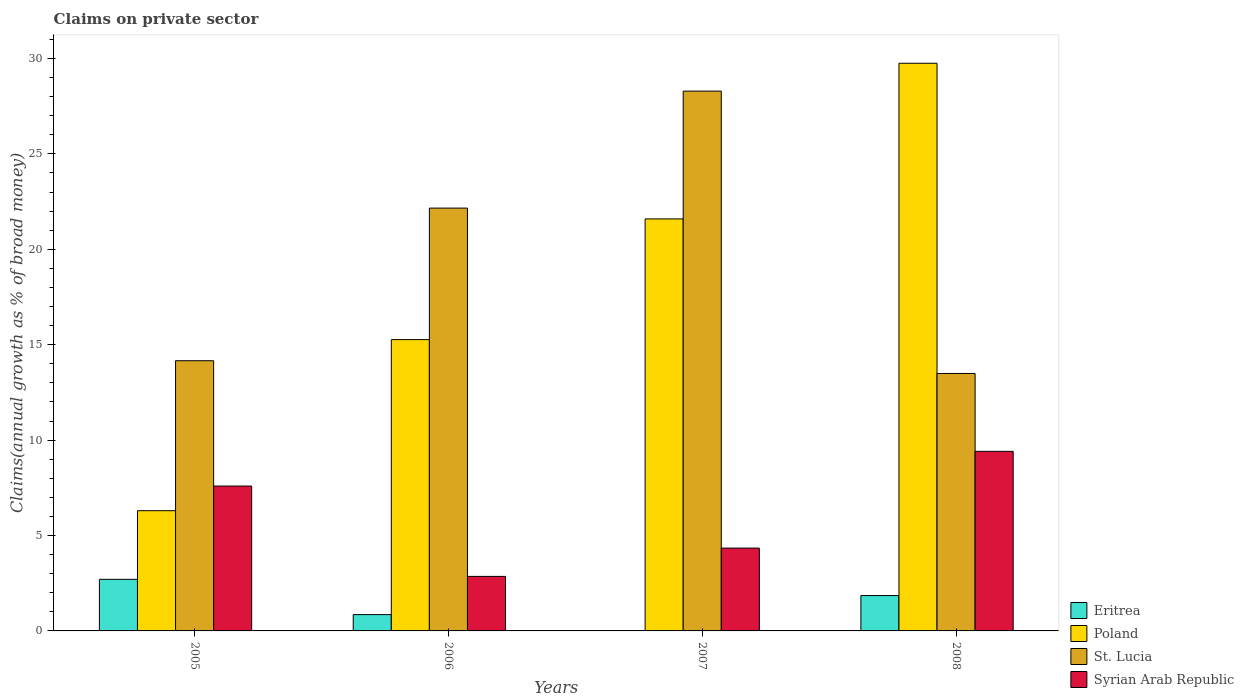How many different coloured bars are there?
Keep it short and to the point. 4. How many groups of bars are there?
Your answer should be compact. 4. Are the number of bars on each tick of the X-axis equal?
Make the answer very short. No. How many bars are there on the 4th tick from the left?
Give a very brief answer. 4. What is the label of the 4th group of bars from the left?
Offer a terse response. 2008. In how many cases, is the number of bars for a given year not equal to the number of legend labels?
Offer a very short reply. 1. What is the percentage of broad money claimed on private sector in Eritrea in 2006?
Offer a very short reply. 0.86. Across all years, what is the maximum percentage of broad money claimed on private sector in St. Lucia?
Keep it short and to the point. 28.29. Across all years, what is the minimum percentage of broad money claimed on private sector in Syrian Arab Republic?
Give a very brief answer. 2.86. In which year was the percentage of broad money claimed on private sector in St. Lucia maximum?
Give a very brief answer. 2007. What is the total percentage of broad money claimed on private sector in Poland in the graph?
Your answer should be very brief. 72.91. What is the difference between the percentage of broad money claimed on private sector in St. Lucia in 2007 and that in 2008?
Your response must be concise. 14.8. What is the difference between the percentage of broad money claimed on private sector in St. Lucia in 2007 and the percentage of broad money claimed on private sector in Poland in 2006?
Ensure brevity in your answer.  13.02. What is the average percentage of broad money claimed on private sector in Syrian Arab Republic per year?
Your answer should be very brief. 6.05. In the year 2008, what is the difference between the percentage of broad money claimed on private sector in Poland and percentage of broad money claimed on private sector in Eritrea?
Your answer should be compact. 27.9. In how many years, is the percentage of broad money claimed on private sector in St. Lucia greater than 16 %?
Ensure brevity in your answer.  2. What is the ratio of the percentage of broad money claimed on private sector in Poland in 2005 to that in 2006?
Make the answer very short. 0.41. What is the difference between the highest and the second highest percentage of broad money claimed on private sector in Eritrea?
Give a very brief answer. 0.85. What is the difference between the highest and the lowest percentage of broad money claimed on private sector in Poland?
Keep it short and to the point. 23.45. How many bars are there?
Your answer should be very brief. 15. What is the difference between two consecutive major ticks on the Y-axis?
Give a very brief answer. 5. Are the values on the major ticks of Y-axis written in scientific E-notation?
Your answer should be compact. No. Does the graph contain any zero values?
Your response must be concise. Yes. Does the graph contain grids?
Provide a short and direct response. No. How many legend labels are there?
Offer a very short reply. 4. How are the legend labels stacked?
Give a very brief answer. Vertical. What is the title of the graph?
Offer a terse response. Claims on private sector. What is the label or title of the Y-axis?
Offer a terse response. Claims(annual growth as % of broad money). What is the Claims(annual growth as % of broad money) in Eritrea in 2005?
Your answer should be very brief. 2.7. What is the Claims(annual growth as % of broad money) of Poland in 2005?
Offer a terse response. 6.3. What is the Claims(annual growth as % of broad money) in St. Lucia in 2005?
Offer a terse response. 14.16. What is the Claims(annual growth as % of broad money) of Syrian Arab Republic in 2005?
Offer a terse response. 7.59. What is the Claims(annual growth as % of broad money) of Eritrea in 2006?
Offer a terse response. 0.86. What is the Claims(annual growth as % of broad money) of Poland in 2006?
Ensure brevity in your answer.  15.27. What is the Claims(annual growth as % of broad money) in St. Lucia in 2006?
Your answer should be compact. 22.16. What is the Claims(annual growth as % of broad money) of Syrian Arab Republic in 2006?
Your answer should be very brief. 2.86. What is the Claims(annual growth as % of broad money) in Eritrea in 2007?
Provide a short and direct response. 0. What is the Claims(annual growth as % of broad money) of Poland in 2007?
Your answer should be compact. 21.59. What is the Claims(annual growth as % of broad money) of St. Lucia in 2007?
Give a very brief answer. 28.29. What is the Claims(annual growth as % of broad money) of Syrian Arab Republic in 2007?
Ensure brevity in your answer.  4.34. What is the Claims(annual growth as % of broad money) of Eritrea in 2008?
Provide a short and direct response. 1.85. What is the Claims(annual growth as % of broad money) in Poland in 2008?
Keep it short and to the point. 29.75. What is the Claims(annual growth as % of broad money) in St. Lucia in 2008?
Provide a short and direct response. 13.49. What is the Claims(annual growth as % of broad money) of Syrian Arab Republic in 2008?
Your answer should be very brief. 9.41. Across all years, what is the maximum Claims(annual growth as % of broad money) in Eritrea?
Your answer should be compact. 2.7. Across all years, what is the maximum Claims(annual growth as % of broad money) in Poland?
Make the answer very short. 29.75. Across all years, what is the maximum Claims(annual growth as % of broad money) in St. Lucia?
Offer a very short reply. 28.29. Across all years, what is the maximum Claims(annual growth as % of broad money) of Syrian Arab Republic?
Your response must be concise. 9.41. Across all years, what is the minimum Claims(annual growth as % of broad money) of Eritrea?
Give a very brief answer. 0. Across all years, what is the minimum Claims(annual growth as % of broad money) of Poland?
Your answer should be very brief. 6.3. Across all years, what is the minimum Claims(annual growth as % of broad money) in St. Lucia?
Make the answer very short. 13.49. Across all years, what is the minimum Claims(annual growth as % of broad money) in Syrian Arab Republic?
Your answer should be compact. 2.86. What is the total Claims(annual growth as % of broad money) in Eritrea in the graph?
Provide a succinct answer. 5.41. What is the total Claims(annual growth as % of broad money) in Poland in the graph?
Offer a terse response. 72.91. What is the total Claims(annual growth as % of broad money) of St. Lucia in the graph?
Provide a short and direct response. 78.1. What is the total Claims(annual growth as % of broad money) in Syrian Arab Republic in the graph?
Offer a very short reply. 24.2. What is the difference between the Claims(annual growth as % of broad money) of Eritrea in 2005 and that in 2006?
Provide a short and direct response. 1.85. What is the difference between the Claims(annual growth as % of broad money) of Poland in 2005 and that in 2006?
Offer a terse response. -8.97. What is the difference between the Claims(annual growth as % of broad money) of St. Lucia in 2005 and that in 2006?
Keep it short and to the point. -8. What is the difference between the Claims(annual growth as % of broad money) of Syrian Arab Republic in 2005 and that in 2006?
Offer a very short reply. 4.74. What is the difference between the Claims(annual growth as % of broad money) in Poland in 2005 and that in 2007?
Keep it short and to the point. -15.29. What is the difference between the Claims(annual growth as % of broad money) in St. Lucia in 2005 and that in 2007?
Your answer should be compact. -14.13. What is the difference between the Claims(annual growth as % of broad money) of Syrian Arab Republic in 2005 and that in 2007?
Provide a succinct answer. 3.25. What is the difference between the Claims(annual growth as % of broad money) of Eritrea in 2005 and that in 2008?
Give a very brief answer. 0.85. What is the difference between the Claims(annual growth as % of broad money) in Poland in 2005 and that in 2008?
Offer a terse response. -23.45. What is the difference between the Claims(annual growth as % of broad money) of St. Lucia in 2005 and that in 2008?
Make the answer very short. 0.67. What is the difference between the Claims(annual growth as % of broad money) of Syrian Arab Republic in 2005 and that in 2008?
Provide a succinct answer. -1.82. What is the difference between the Claims(annual growth as % of broad money) of Poland in 2006 and that in 2007?
Provide a succinct answer. -6.33. What is the difference between the Claims(annual growth as % of broad money) of St. Lucia in 2006 and that in 2007?
Ensure brevity in your answer.  -6.13. What is the difference between the Claims(annual growth as % of broad money) in Syrian Arab Republic in 2006 and that in 2007?
Keep it short and to the point. -1.48. What is the difference between the Claims(annual growth as % of broad money) of Eritrea in 2006 and that in 2008?
Offer a terse response. -1. What is the difference between the Claims(annual growth as % of broad money) of Poland in 2006 and that in 2008?
Your answer should be very brief. -14.48. What is the difference between the Claims(annual growth as % of broad money) of St. Lucia in 2006 and that in 2008?
Your answer should be very brief. 8.67. What is the difference between the Claims(annual growth as % of broad money) in Syrian Arab Republic in 2006 and that in 2008?
Keep it short and to the point. -6.55. What is the difference between the Claims(annual growth as % of broad money) of Poland in 2007 and that in 2008?
Your answer should be compact. -8.16. What is the difference between the Claims(annual growth as % of broad money) in St. Lucia in 2007 and that in 2008?
Make the answer very short. 14.8. What is the difference between the Claims(annual growth as % of broad money) of Syrian Arab Republic in 2007 and that in 2008?
Provide a short and direct response. -5.07. What is the difference between the Claims(annual growth as % of broad money) of Eritrea in 2005 and the Claims(annual growth as % of broad money) of Poland in 2006?
Your answer should be compact. -12.56. What is the difference between the Claims(annual growth as % of broad money) in Eritrea in 2005 and the Claims(annual growth as % of broad money) in St. Lucia in 2006?
Your response must be concise. -19.46. What is the difference between the Claims(annual growth as % of broad money) of Eritrea in 2005 and the Claims(annual growth as % of broad money) of Syrian Arab Republic in 2006?
Your answer should be compact. -0.15. What is the difference between the Claims(annual growth as % of broad money) of Poland in 2005 and the Claims(annual growth as % of broad money) of St. Lucia in 2006?
Your answer should be compact. -15.86. What is the difference between the Claims(annual growth as % of broad money) of Poland in 2005 and the Claims(annual growth as % of broad money) of Syrian Arab Republic in 2006?
Provide a succinct answer. 3.44. What is the difference between the Claims(annual growth as % of broad money) of St. Lucia in 2005 and the Claims(annual growth as % of broad money) of Syrian Arab Republic in 2006?
Make the answer very short. 11.3. What is the difference between the Claims(annual growth as % of broad money) in Eritrea in 2005 and the Claims(annual growth as % of broad money) in Poland in 2007?
Offer a very short reply. -18.89. What is the difference between the Claims(annual growth as % of broad money) of Eritrea in 2005 and the Claims(annual growth as % of broad money) of St. Lucia in 2007?
Provide a short and direct response. -25.59. What is the difference between the Claims(annual growth as % of broad money) of Eritrea in 2005 and the Claims(annual growth as % of broad money) of Syrian Arab Republic in 2007?
Your response must be concise. -1.64. What is the difference between the Claims(annual growth as % of broad money) in Poland in 2005 and the Claims(annual growth as % of broad money) in St. Lucia in 2007?
Provide a short and direct response. -21.99. What is the difference between the Claims(annual growth as % of broad money) of Poland in 2005 and the Claims(annual growth as % of broad money) of Syrian Arab Republic in 2007?
Your answer should be compact. 1.96. What is the difference between the Claims(annual growth as % of broad money) in St. Lucia in 2005 and the Claims(annual growth as % of broad money) in Syrian Arab Republic in 2007?
Make the answer very short. 9.82. What is the difference between the Claims(annual growth as % of broad money) of Eritrea in 2005 and the Claims(annual growth as % of broad money) of Poland in 2008?
Make the answer very short. -27.05. What is the difference between the Claims(annual growth as % of broad money) in Eritrea in 2005 and the Claims(annual growth as % of broad money) in St. Lucia in 2008?
Your answer should be compact. -10.79. What is the difference between the Claims(annual growth as % of broad money) in Eritrea in 2005 and the Claims(annual growth as % of broad money) in Syrian Arab Republic in 2008?
Provide a short and direct response. -6.71. What is the difference between the Claims(annual growth as % of broad money) of Poland in 2005 and the Claims(annual growth as % of broad money) of St. Lucia in 2008?
Make the answer very short. -7.19. What is the difference between the Claims(annual growth as % of broad money) of Poland in 2005 and the Claims(annual growth as % of broad money) of Syrian Arab Republic in 2008?
Offer a terse response. -3.11. What is the difference between the Claims(annual growth as % of broad money) of St. Lucia in 2005 and the Claims(annual growth as % of broad money) of Syrian Arab Republic in 2008?
Give a very brief answer. 4.75. What is the difference between the Claims(annual growth as % of broad money) of Eritrea in 2006 and the Claims(annual growth as % of broad money) of Poland in 2007?
Your answer should be compact. -20.74. What is the difference between the Claims(annual growth as % of broad money) in Eritrea in 2006 and the Claims(annual growth as % of broad money) in St. Lucia in 2007?
Your response must be concise. -27.44. What is the difference between the Claims(annual growth as % of broad money) of Eritrea in 2006 and the Claims(annual growth as % of broad money) of Syrian Arab Republic in 2007?
Your response must be concise. -3.49. What is the difference between the Claims(annual growth as % of broad money) in Poland in 2006 and the Claims(annual growth as % of broad money) in St. Lucia in 2007?
Your response must be concise. -13.02. What is the difference between the Claims(annual growth as % of broad money) in Poland in 2006 and the Claims(annual growth as % of broad money) in Syrian Arab Republic in 2007?
Offer a terse response. 10.93. What is the difference between the Claims(annual growth as % of broad money) of St. Lucia in 2006 and the Claims(annual growth as % of broad money) of Syrian Arab Republic in 2007?
Provide a short and direct response. 17.82. What is the difference between the Claims(annual growth as % of broad money) of Eritrea in 2006 and the Claims(annual growth as % of broad money) of Poland in 2008?
Your response must be concise. -28.9. What is the difference between the Claims(annual growth as % of broad money) in Eritrea in 2006 and the Claims(annual growth as % of broad money) in St. Lucia in 2008?
Ensure brevity in your answer.  -12.64. What is the difference between the Claims(annual growth as % of broad money) of Eritrea in 2006 and the Claims(annual growth as % of broad money) of Syrian Arab Republic in 2008?
Offer a terse response. -8.56. What is the difference between the Claims(annual growth as % of broad money) of Poland in 2006 and the Claims(annual growth as % of broad money) of St. Lucia in 2008?
Give a very brief answer. 1.78. What is the difference between the Claims(annual growth as % of broad money) of Poland in 2006 and the Claims(annual growth as % of broad money) of Syrian Arab Republic in 2008?
Make the answer very short. 5.86. What is the difference between the Claims(annual growth as % of broad money) of St. Lucia in 2006 and the Claims(annual growth as % of broad money) of Syrian Arab Republic in 2008?
Provide a short and direct response. 12.75. What is the difference between the Claims(annual growth as % of broad money) of Poland in 2007 and the Claims(annual growth as % of broad money) of St. Lucia in 2008?
Your answer should be very brief. 8.1. What is the difference between the Claims(annual growth as % of broad money) in Poland in 2007 and the Claims(annual growth as % of broad money) in Syrian Arab Republic in 2008?
Give a very brief answer. 12.18. What is the difference between the Claims(annual growth as % of broad money) in St. Lucia in 2007 and the Claims(annual growth as % of broad money) in Syrian Arab Republic in 2008?
Make the answer very short. 18.88. What is the average Claims(annual growth as % of broad money) in Eritrea per year?
Make the answer very short. 1.35. What is the average Claims(annual growth as % of broad money) in Poland per year?
Make the answer very short. 18.23. What is the average Claims(annual growth as % of broad money) of St. Lucia per year?
Your response must be concise. 19.53. What is the average Claims(annual growth as % of broad money) of Syrian Arab Republic per year?
Offer a terse response. 6.05. In the year 2005, what is the difference between the Claims(annual growth as % of broad money) in Eritrea and Claims(annual growth as % of broad money) in Poland?
Offer a terse response. -3.6. In the year 2005, what is the difference between the Claims(annual growth as % of broad money) of Eritrea and Claims(annual growth as % of broad money) of St. Lucia?
Your answer should be very brief. -11.46. In the year 2005, what is the difference between the Claims(annual growth as % of broad money) in Eritrea and Claims(annual growth as % of broad money) in Syrian Arab Republic?
Your answer should be very brief. -4.89. In the year 2005, what is the difference between the Claims(annual growth as % of broad money) of Poland and Claims(annual growth as % of broad money) of St. Lucia?
Keep it short and to the point. -7.86. In the year 2005, what is the difference between the Claims(annual growth as % of broad money) in Poland and Claims(annual growth as % of broad money) in Syrian Arab Republic?
Keep it short and to the point. -1.29. In the year 2005, what is the difference between the Claims(annual growth as % of broad money) of St. Lucia and Claims(annual growth as % of broad money) of Syrian Arab Republic?
Provide a short and direct response. 6.57. In the year 2006, what is the difference between the Claims(annual growth as % of broad money) in Eritrea and Claims(annual growth as % of broad money) in Poland?
Your answer should be very brief. -14.41. In the year 2006, what is the difference between the Claims(annual growth as % of broad money) of Eritrea and Claims(annual growth as % of broad money) of St. Lucia?
Your answer should be compact. -21.3. In the year 2006, what is the difference between the Claims(annual growth as % of broad money) of Eritrea and Claims(annual growth as % of broad money) of Syrian Arab Republic?
Make the answer very short. -2. In the year 2006, what is the difference between the Claims(annual growth as % of broad money) in Poland and Claims(annual growth as % of broad money) in St. Lucia?
Give a very brief answer. -6.89. In the year 2006, what is the difference between the Claims(annual growth as % of broad money) in Poland and Claims(annual growth as % of broad money) in Syrian Arab Republic?
Offer a terse response. 12.41. In the year 2006, what is the difference between the Claims(annual growth as % of broad money) in St. Lucia and Claims(annual growth as % of broad money) in Syrian Arab Republic?
Offer a terse response. 19.3. In the year 2007, what is the difference between the Claims(annual growth as % of broad money) in Poland and Claims(annual growth as % of broad money) in St. Lucia?
Ensure brevity in your answer.  -6.7. In the year 2007, what is the difference between the Claims(annual growth as % of broad money) of Poland and Claims(annual growth as % of broad money) of Syrian Arab Republic?
Make the answer very short. 17.25. In the year 2007, what is the difference between the Claims(annual growth as % of broad money) of St. Lucia and Claims(annual growth as % of broad money) of Syrian Arab Republic?
Give a very brief answer. 23.95. In the year 2008, what is the difference between the Claims(annual growth as % of broad money) in Eritrea and Claims(annual growth as % of broad money) in Poland?
Offer a very short reply. -27.9. In the year 2008, what is the difference between the Claims(annual growth as % of broad money) in Eritrea and Claims(annual growth as % of broad money) in St. Lucia?
Make the answer very short. -11.64. In the year 2008, what is the difference between the Claims(annual growth as % of broad money) in Eritrea and Claims(annual growth as % of broad money) in Syrian Arab Republic?
Offer a very short reply. -7.56. In the year 2008, what is the difference between the Claims(annual growth as % of broad money) in Poland and Claims(annual growth as % of broad money) in St. Lucia?
Provide a short and direct response. 16.26. In the year 2008, what is the difference between the Claims(annual growth as % of broad money) in Poland and Claims(annual growth as % of broad money) in Syrian Arab Republic?
Provide a short and direct response. 20.34. In the year 2008, what is the difference between the Claims(annual growth as % of broad money) in St. Lucia and Claims(annual growth as % of broad money) in Syrian Arab Republic?
Your answer should be very brief. 4.08. What is the ratio of the Claims(annual growth as % of broad money) of Eritrea in 2005 to that in 2006?
Make the answer very short. 3.16. What is the ratio of the Claims(annual growth as % of broad money) in Poland in 2005 to that in 2006?
Offer a terse response. 0.41. What is the ratio of the Claims(annual growth as % of broad money) of St. Lucia in 2005 to that in 2006?
Provide a succinct answer. 0.64. What is the ratio of the Claims(annual growth as % of broad money) in Syrian Arab Republic in 2005 to that in 2006?
Provide a short and direct response. 2.66. What is the ratio of the Claims(annual growth as % of broad money) of Poland in 2005 to that in 2007?
Your response must be concise. 0.29. What is the ratio of the Claims(annual growth as % of broad money) in St. Lucia in 2005 to that in 2007?
Ensure brevity in your answer.  0.5. What is the ratio of the Claims(annual growth as % of broad money) of Syrian Arab Republic in 2005 to that in 2007?
Offer a very short reply. 1.75. What is the ratio of the Claims(annual growth as % of broad money) of Eritrea in 2005 to that in 2008?
Your answer should be very brief. 1.46. What is the ratio of the Claims(annual growth as % of broad money) of Poland in 2005 to that in 2008?
Your answer should be very brief. 0.21. What is the ratio of the Claims(annual growth as % of broad money) in St. Lucia in 2005 to that in 2008?
Provide a short and direct response. 1.05. What is the ratio of the Claims(annual growth as % of broad money) of Syrian Arab Republic in 2005 to that in 2008?
Offer a very short reply. 0.81. What is the ratio of the Claims(annual growth as % of broad money) of Poland in 2006 to that in 2007?
Make the answer very short. 0.71. What is the ratio of the Claims(annual growth as % of broad money) of St. Lucia in 2006 to that in 2007?
Provide a succinct answer. 0.78. What is the ratio of the Claims(annual growth as % of broad money) in Syrian Arab Republic in 2006 to that in 2007?
Offer a very short reply. 0.66. What is the ratio of the Claims(annual growth as % of broad money) of Eritrea in 2006 to that in 2008?
Keep it short and to the point. 0.46. What is the ratio of the Claims(annual growth as % of broad money) in Poland in 2006 to that in 2008?
Offer a terse response. 0.51. What is the ratio of the Claims(annual growth as % of broad money) of St. Lucia in 2006 to that in 2008?
Your answer should be compact. 1.64. What is the ratio of the Claims(annual growth as % of broad money) of Syrian Arab Republic in 2006 to that in 2008?
Your answer should be compact. 0.3. What is the ratio of the Claims(annual growth as % of broad money) in Poland in 2007 to that in 2008?
Your response must be concise. 0.73. What is the ratio of the Claims(annual growth as % of broad money) of St. Lucia in 2007 to that in 2008?
Give a very brief answer. 2.1. What is the ratio of the Claims(annual growth as % of broad money) in Syrian Arab Republic in 2007 to that in 2008?
Your response must be concise. 0.46. What is the difference between the highest and the second highest Claims(annual growth as % of broad money) of Eritrea?
Make the answer very short. 0.85. What is the difference between the highest and the second highest Claims(annual growth as % of broad money) of Poland?
Provide a short and direct response. 8.16. What is the difference between the highest and the second highest Claims(annual growth as % of broad money) of St. Lucia?
Offer a very short reply. 6.13. What is the difference between the highest and the second highest Claims(annual growth as % of broad money) in Syrian Arab Republic?
Keep it short and to the point. 1.82. What is the difference between the highest and the lowest Claims(annual growth as % of broad money) in Eritrea?
Your response must be concise. 2.7. What is the difference between the highest and the lowest Claims(annual growth as % of broad money) in Poland?
Give a very brief answer. 23.45. What is the difference between the highest and the lowest Claims(annual growth as % of broad money) in St. Lucia?
Offer a very short reply. 14.8. What is the difference between the highest and the lowest Claims(annual growth as % of broad money) of Syrian Arab Republic?
Give a very brief answer. 6.55. 